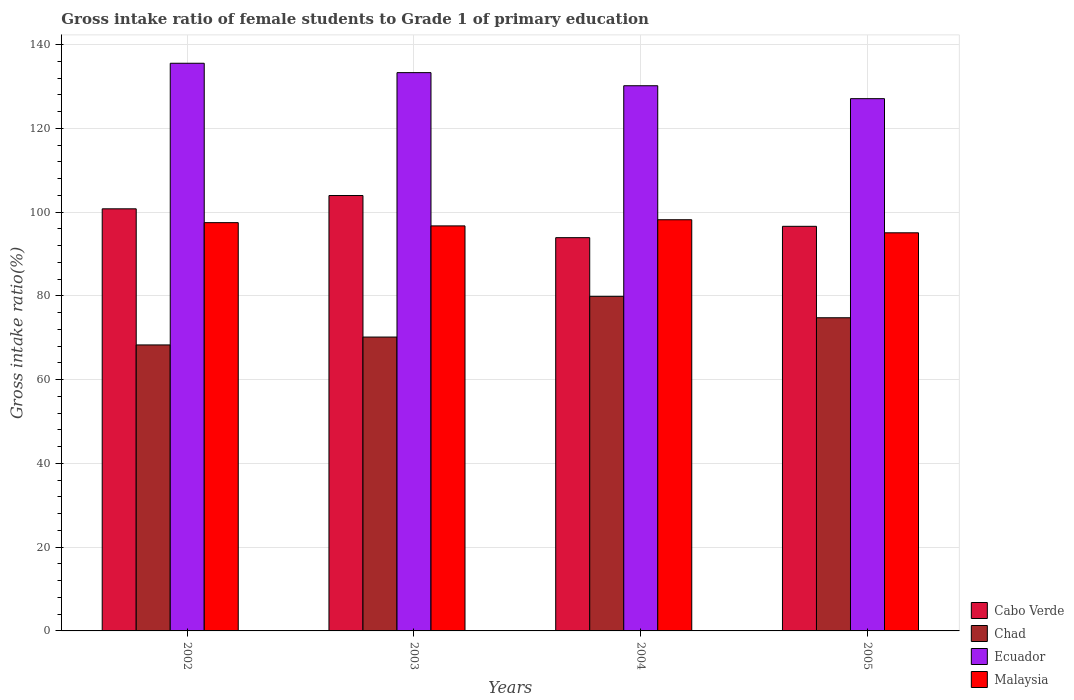How many groups of bars are there?
Your answer should be very brief. 4. Are the number of bars per tick equal to the number of legend labels?
Keep it short and to the point. Yes. Are the number of bars on each tick of the X-axis equal?
Provide a short and direct response. Yes. How many bars are there on the 2nd tick from the left?
Provide a succinct answer. 4. How many bars are there on the 1st tick from the right?
Your answer should be very brief. 4. In how many cases, is the number of bars for a given year not equal to the number of legend labels?
Your response must be concise. 0. What is the gross intake ratio in Chad in 2004?
Your response must be concise. 79.89. Across all years, what is the maximum gross intake ratio in Cabo Verde?
Offer a very short reply. 103.96. Across all years, what is the minimum gross intake ratio in Ecuador?
Ensure brevity in your answer.  127.08. In which year was the gross intake ratio in Malaysia minimum?
Provide a short and direct response. 2005. What is the total gross intake ratio in Ecuador in the graph?
Your response must be concise. 526.09. What is the difference between the gross intake ratio in Malaysia in 2002 and that in 2003?
Your response must be concise. 0.78. What is the difference between the gross intake ratio in Ecuador in 2002 and the gross intake ratio in Chad in 2004?
Your answer should be very brief. 55.65. What is the average gross intake ratio in Malaysia per year?
Provide a succinct answer. 96.86. In the year 2002, what is the difference between the gross intake ratio in Chad and gross intake ratio in Ecuador?
Offer a terse response. -67.25. What is the ratio of the gross intake ratio in Cabo Verde in 2002 to that in 2004?
Make the answer very short. 1.07. Is the difference between the gross intake ratio in Chad in 2004 and 2005 greater than the difference between the gross intake ratio in Ecuador in 2004 and 2005?
Give a very brief answer. Yes. What is the difference between the highest and the second highest gross intake ratio in Malaysia?
Make the answer very short. 0.69. What is the difference between the highest and the lowest gross intake ratio in Malaysia?
Give a very brief answer. 3.12. In how many years, is the gross intake ratio in Chad greater than the average gross intake ratio in Chad taken over all years?
Your answer should be compact. 2. Is the sum of the gross intake ratio in Malaysia in 2002 and 2003 greater than the maximum gross intake ratio in Chad across all years?
Give a very brief answer. Yes. What does the 1st bar from the left in 2005 represents?
Offer a terse response. Cabo Verde. What does the 4th bar from the right in 2003 represents?
Ensure brevity in your answer.  Cabo Verde. Is it the case that in every year, the sum of the gross intake ratio in Cabo Verde and gross intake ratio in Chad is greater than the gross intake ratio in Malaysia?
Make the answer very short. Yes. Are all the bars in the graph horizontal?
Give a very brief answer. No. How many years are there in the graph?
Offer a very short reply. 4. What is the difference between two consecutive major ticks on the Y-axis?
Provide a short and direct response. 20. Are the values on the major ticks of Y-axis written in scientific E-notation?
Your answer should be compact. No. Does the graph contain grids?
Your answer should be very brief. Yes. How many legend labels are there?
Provide a short and direct response. 4. What is the title of the graph?
Provide a short and direct response. Gross intake ratio of female students to Grade 1 of primary education. Does "Virgin Islands" appear as one of the legend labels in the graph?
Your answer should be very brief. No. What is the label or title of the X-axis?
Your answer should be compact. Years. What is the label or title of the Y-axis?
Provide a succinct answer. Gross intake ratio(%). What is the Gross intake ratio(%) of Cabo Verde in 2002?
Make the answer very short. 100.78. What is the Gross intake ratio(%) of Chad in 2002?
Provide a short and direct response. 68.29. What is the Gross intake ratio(%) of Ecuador in 2002?
Give a very brief answer. 135.54. What is the Gross intake ratio(%) in Malaysia in 2002?
Offer a terse response. 97.48. What is the Gross intake ratio(%) in Cabo Verde in 2003?
Offer a terse response. 103.96. What is the Gross intake ratio(%) of Chad in 2003?
Keep it short and to the point. 70.17. What is the Gross intake ratio(%) in Ecuador in 2003?
Offer a very short reply. 133.3. What is the Gross intake ratio(%) in Malaysia in 2003?
Your answer should be compact. 96.71. What is the Gross intake ratio(%) of Cabo Verde in 2004?
Ensure brevity in your answer.  93.9. What is the Gross intake ratio(%) in Chad in 2004?
Your response must be concise. 79.89. What is the Gross intake ratio(%) of Ecuador in 2004?
Your answer should be very brief. 130.17. What is the Gross intake ratio(%) in Malaysia in 2004?
Your answer should be compact. 98.18. What is the Gross intake ratio(%) in Cabo Verde in 2005?
Your answer should be very brief. 96.61. What is the Gross intake ratio(%) in Chad in 2005?
Your response must be concise. 74.77. What is the Gross intake ratio(%) in Ecuador in 2005?
Offer a very short reply. 127.08. What is the Gross intake ratio(%) of Malaysia in 2005?
Your answer should be very brief. 95.06. Across all years, what is the maximum Gross intake ratio(%) in Cabo Verde?
Make the answer very short. 103.96. Across all years, what is the maximum Gross intake ratio(%) in Chad?
Your answer should be very brief. 79.89. Across all years, what is the maximum Gross intake ratio(%) of Ecuador?
Ensure brevity in your answer.  135.54. Across all years, what is the maximum Gross intake ratio(%) of Malaysia?
Your answer should be compact. 98.18. Across all years, what is the minimum Gross intake ratio(%) of Cabo Verde?
Offer a terse response. 93.9. Across all years, what is the minimum Gross intake ratio(%) of Chad?
Offer a very short reply. 68.29. Across all years, what is the minimum Gross intake ratio(%) in Ecuador?
Offer a terse response. 127.08. Across all years, what is the minimum Gross intake ratio(%) of Malaysia?
Offer a terse response. 95.06. What is the total Gross intake ratio(%) in Cabo Verde in the graph?
Keep it short and to the point. 395.25. What is the total Gross intake ratio(%) of Chad in the graph?
Provide a short and direct response. 293.11. What is the total Gross intake ratio(%) in Ecuador in the graph?
Make the answer very short. 526.09. What is the total Gross intake ratio(%) of Malaysia in the graph?
Provide a short and direct response. 387.42. What is the difference between the Gross intake ratio(%) in Cabo Verde in 2002 and that in 2003?
Give a very brief answer. -3.17. What is the difference between the Gross intake ratio(%) of Chad in 2002 and that in 2003?
Ensure brevity in your answer.  -1.88. What is the difference between the Gross intake ratio(%) of Ecuador in 2002 and that in 2003?
Offer a very short reply. 2.24. What is the difference between the Gross intake ratio(%) of Malaysia in 2002 and that in 2003?
Keep it short and to the point. 0.78. What is the difference between the Gross intake ratio(%) of Cabo Verde in 2002 and that in 2004?
Offer a very short reply. 6.89. What is the difference between the Gross intake ratio(%) in Chad in 2002 and that in 2004?
Your response must be concise. -11.6. What is the difference between the Gross intake ratio(%) in Ecuador in 2002 and that in 2004?
Your answer should be compact. 5.37. What is the difference between the Gross intake ratio(%) in Malaysia in 2002 and that in 2004?
Keep it short and to the point. -0.69. What is the difference between the Gross intake ratio(%) in Cabo Verde in 2002 and that in 2005?
Your answer should be compact. 4.18. What is the difference between the Gross intake ratio(%) in Chad in 2002 and that in 2005?
Your answer should be very brief. -6.49. What is the difference between the Gross intake ratio(%) of Ecuador in 2002 and that in 2005?
Keep it short and to the point. 8.45. What is the difference between the Gross intake ratio(%) of Malaysia in 2002 and that in 2005?
Your answer should be compact. 2.43. What is the difference between the Gross intake ratio(%) of Cabo Verde in 2003 and that in 2004?
Provide a short and direct response. 10.06. What is the difference between the Gross intake ratio(%) in Chad in 2003 and that in 2004?
Keep it short and to the point. -9.72. What is the difference between the Gross intake ratio(%) of Ecuador in 2003 and that in 2004?
Your answer should be very brief. 3.13. What is the difference between the Gross intake ratio(%) of Malaysia in 2003 and that in 2004?
Your response must be concise. -1.47. What is the difference between the Gross intake ratio(%) in Cabo Verde in 2003 and that in 2005?
Provide a short and direct response. 7.35. What is the difference between the Gross intake ratio(%) in Chad in 2003 and that in 2005?
Make the answer very short. -4.61. What is the difference between the Gross intake ratio(%) of Ecuador in 2003 and that in 2005?
Offer a terse response. 6.21. What is the difference between the Gross intake ratio(%) in Malaysia in 2003 and that in 2005?
Provide a succinct answer. 1.65. What is the difference between the Gross intake ratio(%) of Cabo Verde in 2004 and that in 2005?
Provide a succinct answer. -2.71. What is the difference between the Gross intake ratio(%) in Chad in 2004 and that in 2005?
Make the answer very short. 5.11. What is the difference between the Gross intake ratio(%) of Ecuador in 2004 and that in 2005?
Your answer should be compact. 3.09. What is the difference between the Gross intake ratio(%) in Malaysia in 2004 and that in 2005?
Offer a terse response. 3.12. What is the difference between the Gross intake ratio(%) in Cabo Verde in 2002 and the Gross intake ratio(%) in Chad in 2003?
Give a very brief answer. 30.62. What is the difference between the Gross intake ratio(%) of Cabo Verde in 2002 and the Gross intake ratio(%) of Ecuador in 2003?
Offer a very short reply. -32.51. What is the difference between the Gross intake ratio(%) of Cabo Verde in 2002 and the Gross intake ratio(%) of Malaysia in 2003?
Your answer should be very brief. 4.08. What is the difference between the Gross intake ratio(%) in Chad in 2002 and the Gross intake ratio(%) in Ecuador in 2003?
Your response must be concise. -65.01. What is the difference between the Gross intake ratio(%) of Chad in 2002 and the Gross intake ratio(%) of Malaysia in 2003?
Your answer should be compact. -28.42. What is the difference between the Gross intake ratio(%) of Ecuador in 2002 and the Gross intake ratio(%) of Malaysia in 2003?
Provide a succinct answer. 38.83. What is the difference between the Gross intake ratio(%) of Cabo Verde in 2002 and the Gross intake ratio(%) of Chad in 2004?
Your answer should be compact. 20.9. What is the difference between the Gross intake ratio(%) of Cabo Verde in 2002 and the Gross intake ratio(%) of Ecuador in 2004?
Keep it short and to the point. -29.39. What is the difference between the Gross intake ratio(%) in Cabo Verde in 2002 and the Gross intake ratio(%) in Malaysia in 2004?
Give a very brief answer. 2.61. What is the difference between the Gross intake ratio(%) of Chad in 2002 and the Gross intake ratio(%) of Ecuador in 2004?
Make the answer very short. -61.89. What is the difference between the Gross intake ratio(%) in Chad in 2002 and the Gross intake ratio(%) in Malaysia in 2004?
Keep it short and to the point. -29.89. What is the difference between the Gross intake ratio(%) of Ecuador in 2002 and the Gross intake ratio(%) of Malaysia in 2004?
Provide a short and direct response. 37.36. What is the difference between the Gross intake ratio(%) of Cabo Verde in 2002 and the Gross intake ratio(%) of Chad in 2005?
Your answer should be very brief. 26.01. What is the difference between the Gross intake ratio(%) in Cabo Verde in 2002 and the Gross intake ratio(%) in Ecuador in 2005?
Your answer should be compact. -26.3. What is the difference between the Gross intake ratio(%) in Cabo Verde in 2002 and the Gross intake ratio(%) in Malaysia in 2005?
Your answer should be very brief. 5.73. What is the difference between the Gross intake ratio(%) of Chad in 2002 and the Gross intake ratio(%) of Ecuador in 2005?
Provide a succinct answer. -58.8. What is the difference between the Gross intake ratio(%) in Chad in 2002 and the Gross intake ratio(%) in Malaysia in 2005?
Give a very brief answer. -26.77. What is the difference between the Gross intake ratio(%) in Ecuador in 2002 and the Gross intake ratio(%) in Malaysia in 2005?
Keep it short and to the point. 40.48. What is the difference between the Gross intake ratio(%) in Cabo Verde in 2003 and the Gross intake ratio(%) in Chad in 2004?
Your answer should be compact. 24.07. What is the difference between the Gross intake ratio(%) in Cabo Verde in 2003 and the Gross intake ratio(%) in Ecuador in 2004?
Your answer should be very brief. -26.21. What is the difference between the Gross intake ratio(%) of Cabo Verde in 2003 and the Gross intake ratio(%) of Malaysia in 2004?
Ensure brevity in your answer.  5.78. What is the difference between the Gross intake ratio(%) of Chad in 2003 and the Gross intake ratio(%) of Ecuador in 2004?
Your answer should be compact. -60. What is the difference between the Gross intake ratio(%) in Chad in 2003 and the Gross intake ratio(%) in Malaysia in 2004?
Make the answer very short. -28.01. What is the difference between the Gross intake ratio(%) in Ecuador in 2003 and the Gross intake ratio(%) in Malaysia in 2004?
Ensure brevity in your answer.  35.12. What is the difference between the Gross intake ratio(%) in Cabo Verde in 2003 and the Gross intake ratio(%) in Chad in 2005?
Make the answer very short. 29.19. What is the difference between the Gross intake ratio(%) of Cabo Verde in 2003 and the Gross intake ratio(%) of Ecuador in 2005?
Keep it short and to the point. -23.12. What is the difference between the Gross intake ratio(%) in Cabo Verde in 2003 and the Gross intake ratio(%) in Malaysia in 2005?
Keep it short and to the point. 8.9. What is the difference between the Gross intake ratio(%) in Chad in 2003 and the Gross intake ratio(%) in Ecuador in 2005?
Your response must be concise. -56.92. What is the difference between the Gross intake ratio(%) of Chad in 2003 and the Gross intake ratio(%) of Malaysia in 2005?
Offer a terse response. -24.89. What is the difference between the Gross intake ratio(%) of Ecuador in 2003 and the Gross intake ratio(%) of Malaysia in 2005?
Offer a terse response. 38.24. What is the difference between the Gross intake ratio(%) of Cabo Verde in 2004 and the Gross intake ratio(%) of Chad in 2005?
Provide a succinct answer. 19.13. What is the difference between the Gross intake ratio(%) in Cabo Verde in 2004 and the Gross intake ratio(%) in Ecuador in 2005?
Offer a terse response. -33.19. What is the difference between the Gross intake ratio(%) of Cabo Verde in 2004 and the Gross intake ratio(%) of Malaysia in 2005?
Your answer should be compact. -1.16. What is the difference between the Gross intake ratio(%) in Chad in 2004 and the Gross intake ratio(%) in Ecuador in 2005?
Your response must be concise. -47.2. What is the difference between the Gross intake ratio(%) in Chad in 2004 and the Gross intake ratio(%) in Malaysia in 2005?
Your response must be concise. -15.17. What is the difference between the Gross intake ratio(%) of Ecuador in 2004 and the Gross intake ratio(%) of Malaysia in 2005?
Offer a very short reply. 35.11. What is the average Gross intake ratio(%) of Cabo Verde per year?
Give a very brief answer. 98.81. What is the average Gross intake ratio(%) of Chad per year?
Offer a terse response. 73.28. What is the average Gross intake ratio(%) in Ecuador per year?
Your response must be concise. 131.52. What is the average Gross intake ratio(%) in Malaysia per year?
Offer a terse response. 96.86. In the year 2002, what is the difference between the Gross intake ratio(%) of Cabo Verde and Gross intake ratio(%) of Chad?
Give a very brief answer. 32.5. In the year 2002, what is the difference between the Gross intake ratio(%) in Cabo Verde and Gross intake ratio(%) in Ecuador?
Ensure brevity in your answer.  -34.75. In the year 2002, what is the difference between the Gross intake ratio(%) in Cabo Verde and Gross intake ratio(%) in Malaysia?
Offer a terse response. 3.3. In the year 2002, what is the difference between the Gross intake ratio(%) in Chad and Gross intake ratio(%) in Ecuador?
Offer a very short reply. -67.25. In the year 2002, what is the difference between the Gross intake ratio(%) in Chad and Gross intake ratio(%) in Malaysia?
Make the answer very short. -29.2. In the year 2002, what is the difference between the Gross intake ratio(%) in Ecuador and Gross intake ratio(%) in Malaysia?
Your response must be concise. 38.06. In the year 2003, what is the difference between the Gross intake ratio(%) in Cabo Verde and Gross intake ratio(%) in Chad?
Keep it short and to the point. 33.79. In the year 2003, what is the difference between the Gross intake ratio(%) of Cabo Verde and Gross intake ratio(%) of Ecuador?
Provide a short and direct response. -29.34. In the year 2003, what is the difference between the Gross intake ratio(%) of Cabo Verde and Gross intake ratio(%) of Malaysia?
Your response must be concise. 7.25. In the year 2003, what is the difference between the Gross intake ratio(%) of Chad and Gross intake ratio(%) of Ecuador?
Offer a very short reply. -63.13. In the year 2003, what is the difference between the Gross intake ratio(%) in Chad and Gross intake ratio(%) in Malaysia?
Ensure brevity in your answer.  -26.54. In the year 2003, what is the difference between the Gross intake ratio(%) in Ecuador and Gross intake ratio(%) in Malaysia?
Offer a terse response. 36.59. In the year 2004, what is the difference between the Gross intake ratio(%) of Cabo Verde and Gross intake ratio(%) of Chad?
Ensure brevity in your answer.  14.01. In the year 2004, what is the difference between the Gross intake ratio(%) of Cabo Verde and Gross intake ratio(%) of Ecuador?
Provide a short and direct response. -36.27. In the year 2004, what is the difference between the Gross intake ratio(%) of Cabo Verde and Gross intake ratio(%) of Malaysia?
Make the answer very short. -4.28. In the year 2004, what is the difference between the Gross intake ratio(%) of Chad and Gross intake ratio(%) of Ecuador?
Ensure brevity in your answer.  -50.29. In the year 2004, what is the difference between the Gross intake ratio(%) in Chad and Gross intake ratio(%) in Malaysia?
Your response must be concise. -18.29. In the year 2004, what is the difference between the Gross intake ratio(%) in Ecuador and Gross intake ratio(%) in Malaysia?
Offer a terse response. 31.99. In the year 2005, what is the difference between the Gross intake ratio(%) in Cabo Verde and Gross intake ratio(%) in Chad?
Your response must be concise. 21.83. In the year 2005, what is the difference between the Gross intake ratio(%) of Cabo Verde and Gross intake ratio(%) of Ecuador?
Give a very brief answer. -30.48. In the year 2005, what is the difference between the Gross intake ratio(%) in Cabo Verde and Gross intake ratio(%) in Malaysia?
Your answer should be compact. 1.55. In the year 2005, what is the difference between the Gross intake ratio(%) of Chad and Gross intake ratio(%) of Ecuador?
Your answer should be compact. -52.31. In the year 2005, what is the difference between the Gross intake ratio(%) in Chad and Gross intake ratio(%) in Malaysia?
Offer a terse response. -20.29. In the year 2005, what is the difference between the Gross intake ratio(%) of Ecuador and Gross intake ratio(%) of Malaysia?
Give a very brief answer. 32.03. What is the ratio of the Gross intake ratio(%) in Cabo Verde in 2002 to that in 2003?
Provide a short and direct response. 0.97. What is the ratio of the Gross intake ratio(%) in Chad in 2002 to that in 2003?
Ensure brevity in your answer.  0.97. What is the ratio of the Gross intake ratio(%) in Ecuador in 2002 to that in 2003?
Make the answer very short. 1.02. What is the ratio of the Gross intake ratio(%) of Malaysia in 2002 to that in 2003?
Your answer should be compact. 1.01. What is the ratio of the Gross intake ratio(%) in Cabo Verde in 2002 to that in 2004?
Provide a succinct answer. 1.07. What is the ratio of the Gross intake ratio(%) of Chad in 2002 to that in 2004?
Provide a short and direct response. 0.85. What is the ratio of the Gross intake ratio(%) of Ecuador in 2002 to that in 2004?
Offer a terse response. 1.04. What is the ratio of the Gross intake ratio(%) of Malaysia in 2002 to that in 2004?
Provide a short and direct response. 0.99. What is the ratio of the Gross intake ratio(%) of Cabo Verde in 2002 to that in 2005?
Make the answer very short. 1.04. What is the ratio of the Gross intake ratio(%) of Chad in 2002 to that in 2005?
Ensure brevity in your answer.  0.91. What is the ratio of the Gross intake ratio(%) of Ecuador in 2002 to that in 2005?
Ensure brevity in your answer.  1.07. What is the ratio of the Gross intake ratio(%) in Malaysia in 2002 to that in 2005?
Provide a succinct answer. 1.03. What is the ratio of the Gross intake ratio(%) in Cabo Verde in 2003 to that in 2004?
Make the answer very short. 1.11. What is the ratio of the Gross intake ratio(%) of Chad in 2003 to that in 2004?
Provide a succinct answer. 0.88. What is the ratio of the Gross intake ratio(%) of Ecuador in 2003 to that in 2004?
Provide a succinct answer. 1.02. What is the ratio of the Gross intake ratio(%) in Cabo Verde in 2003 to that in 2005?
Keep it short and to the point. 1.08. What is the ratio of the Gross intake ratio(%) in Chad in 2003 to that in 2005?
Keep it short and to the point. 0.94. What is the ratio of the Gross intake ratio(%) of Ecuador in 2003 to that in 2005?
Offer a terse response. 1.05. What is the ratio of the Gross intake ratio(%) of Malaysia in 2003 to that in 2005?
Give a very brief answer. 1.02. What is the ratio of the Gross intake ratio(%) in Cabo Verde in 2004 to that in 2005?
Your answer should be compact. 0.97. What is the ratio of the Gross intake ratio(%) in Chad in 2004 to that in 2005?
Your answer should be compact. 1.07. What is the ratio of the Gross intake ratio(%) of Ecuador in 2004 to that in 2005?
Provide a succinct answer. 1.02. What is the ratio of the Gross intake ratio(%) in Malaysia in 2004 to that in 2005?
Your answer should be compact. 1.03. What is the difference between the highest and the second highest Gross intake ratio(%) in Cabo Verde?
Make the answer very short. 3.17. What is the difference between the highest and the second highest Gross intake ratio(%) of Chad?
Keep it short and to the point. 5.11. What is the difference between the highest and the second highest Gross intake ratio(%) of Ecuador?
Make the answer very short. 2.24. What is the difference between the highest and the second highest Gross intake ratio(%) of Malaysia?
Make the answer very short. 0.69. What is the difference between the highest and the lowest Gross intake ratio(%) in Cabo Verde?
Provide a short and direct response. 10.06. What is the difference between the highest and the lowest Gross intake ratio(%) of Chad?
Offer a very short reply. 11.6. What is the difference between the highest and the lowest Gross intake ratio(%) in Ecuador?
Your answer should be compact. 8.45. What is the difference between the highest and the lowest Gross intake ratio(%) of Malaysia?
Offer a very short reply. 3.12. 